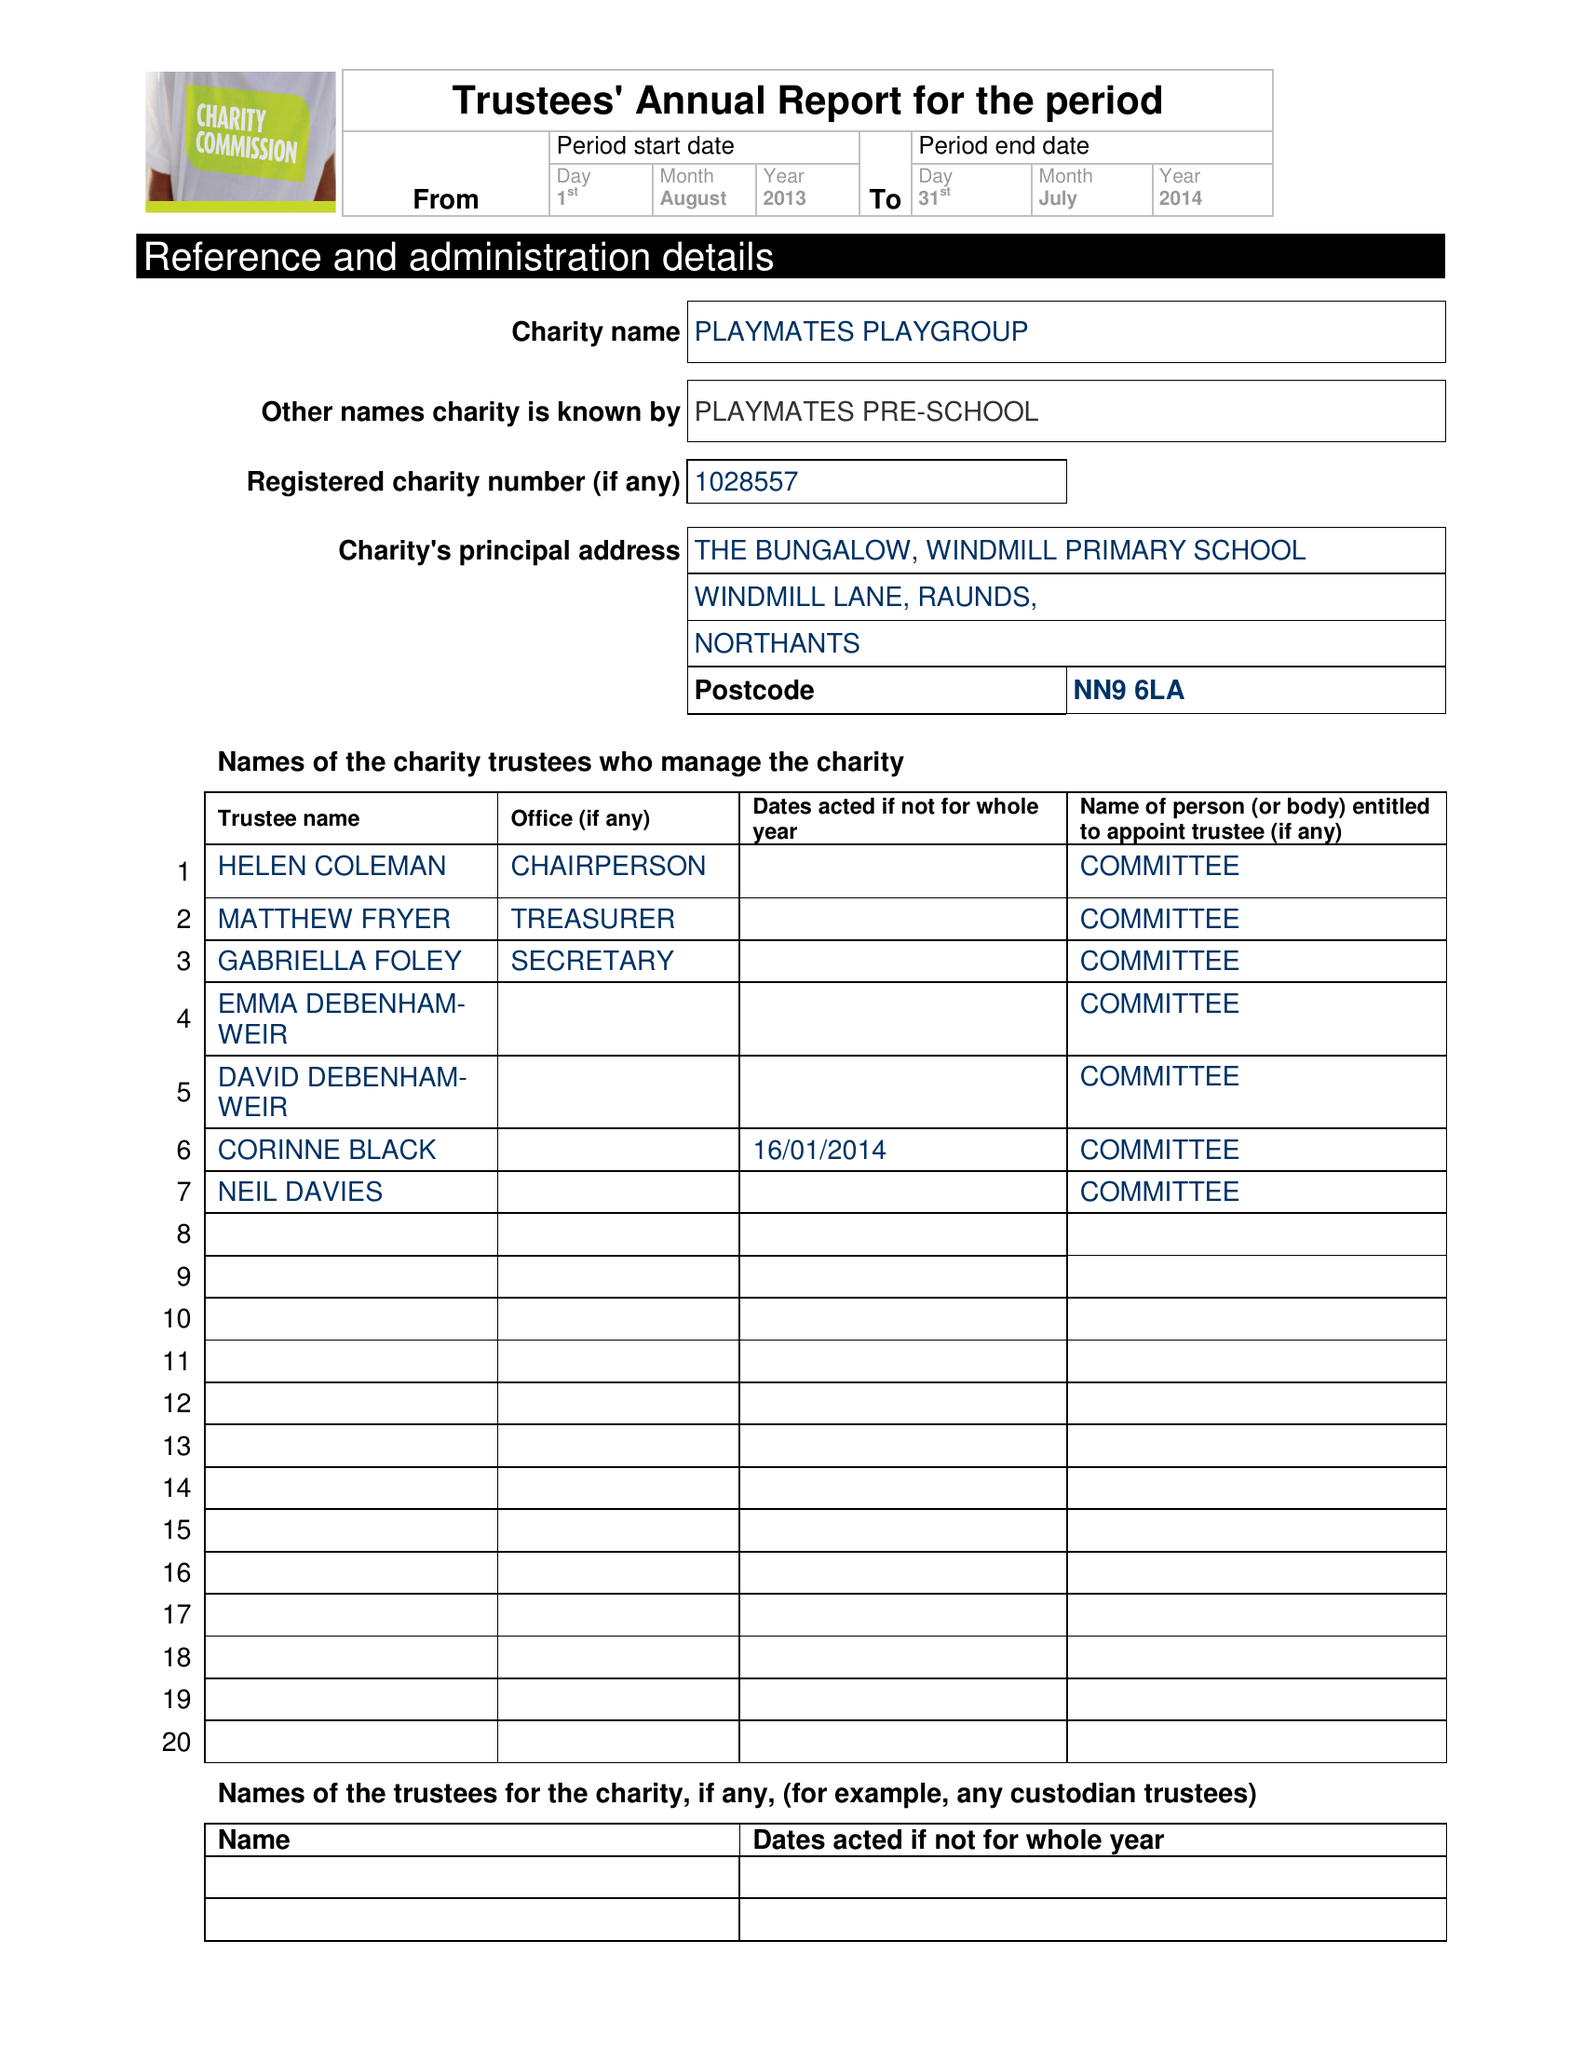What is the value for the spending_annually_in_british_pounds?
Answer the question using a single word or phrase. 62488.13 